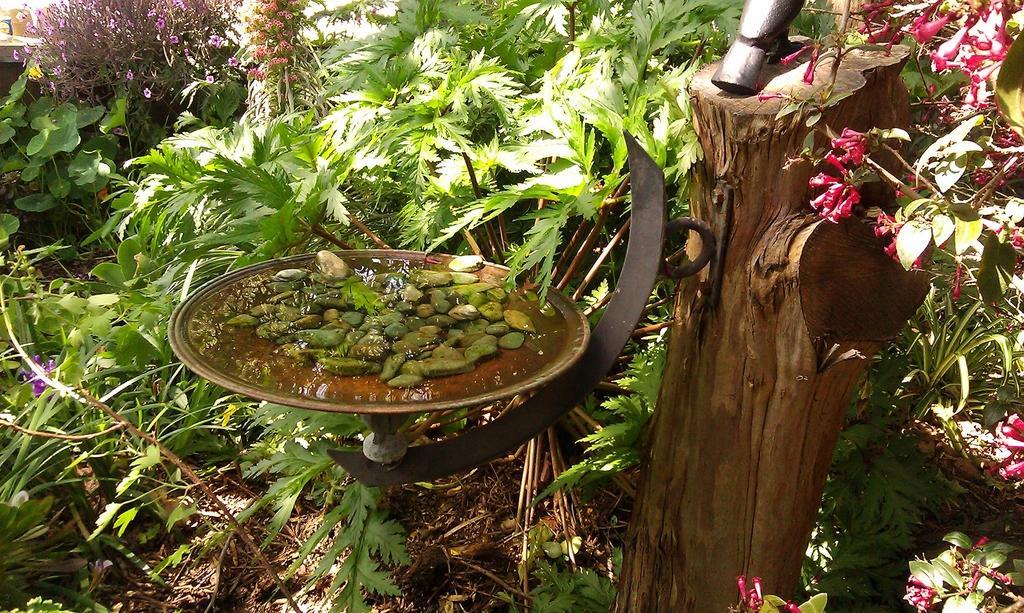Could you give a brief overview of what you see in this image? These are the plants with leaves, branches and colorful flowers. This looks like a tree trunk. I can see a plate filled with water and small rocks. 